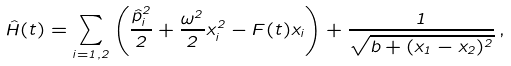Convert formula to latex. <formula><loc_0><loc_0><loc_500><loc_500>\hat { H } ( t ) = \sum _ { i = 1 , 2 } \left ( \frac { \hat { p } _ { i } ^ { 2 } } { 2 } + \frac { \omega ^ { 2 } } { 2 } x _ { i } ^ { 2 } - F ( t ) x _ { i } \right ) + \frac { 1 } { \sqrt { b + ( x _ { 1 } - x _ { 2 } ) ^ { 2 } } } \, ,</formula> 